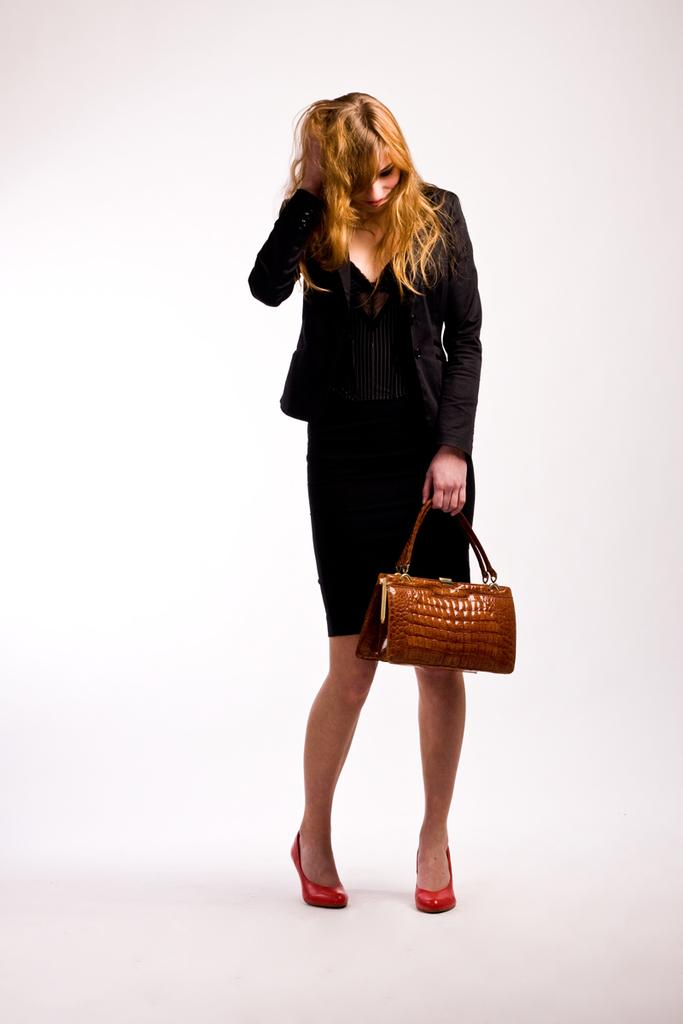Who is the main subject in the image? There is a woman in the image. What is the woman doing in the image? The woman is standing. What object is the woman holding in her hand? The woman is holding a handbag in her hand. How many attempts did the woman make to jump over the fence in the image? There is no fence present in the image, and the woman is not attempting to jump over anything. 